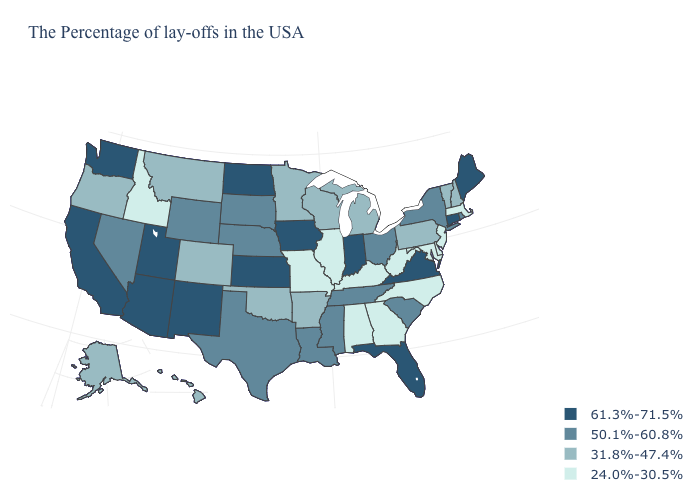Does Maine have the highest value in the Northeast?
Keep it brief. Yes. What is the value of Washington?
Concise answer only. 61.3%-71.5%. Name the states that have a value in the range 50.1%-60.8%?
Quick response, please. Rhode Island, New York, South Carolina, Ohio, Tennessee, Mississippi, Louisiana, Nebraska, Texas, South Dakota, Wyoming, Nevada. Does Wisconsin have the same value as Michigan?
Be succinct. Yes. What is the highest value in the USA?
Be succinct. 61.3%-71.5%. Name the states that have a value in the range 61.3%-71.5%?
Short answer required. Maine, Connecticut, Virginia, Florida, Indiana, Iowa, Kansas, North Dakota, New Mexico, Utah, Arizona, California, Washington. What is the highest value in the USA?
Give a very brief answer. 61.3%-71.5%. What is the value of Utah?
Answer briefly. 61.3%-71.5%. What is the value of Montana?
Quick response, please. 31.8%-47.4%. Name the states that have a value in the range 31.8%-47.4%?
Be succinct. New Hampshire, Vermont, Pennsylvania, Michigan, Wisconsin, Arkansas, Minnesota, Oklahoma, Colorado, Montana, Oregon, Alaska, Hawaii. Which states have the lowest value in the MidWest?
Give a very brief answer. Illinois, Missouri. Name the states that have a value in the range 31.8%-47.4%?
Be succinct. New Hampshire, Vermont, Pennsylvania, Michigan, Wisconsin, Arkansas, Minnesota, Oklahoma, Colorado, Montana, Oregon, Alaska, Hawaii. What is the lowest value in states that border Indiana?
Concise answer only. 24.0%-30.5%. Does the map have missing data?
Concise answer only. No. Among the states that border New Hampshire , does Maine have the highest value?
Give a very brief answer. Yes. 